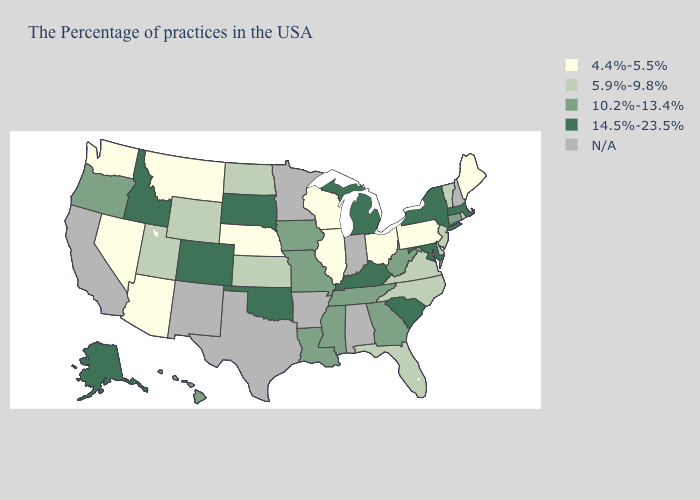What is the value of Maine?
Quick response, please. 4.4%-5.5%. What is the lowest value in the South?
Concise answer only. 5.9%-9.8%. What is the value of Maryland?
Give a very brief answer. 14.5%-23.5%. Name the states that have a value in the range 5.9%-9.8%?
Short answer required. Rhode Island, Vermont, New Jersey, Delaware, Virginia, North Carolina, Florida, Kansas, North Dakota, Wyoming, Utah. What is the lowest value in the USA?
Quick response, please. 4.4%-5.5%. Name the states that have a value in the range N/A?
Keep it brief. New Hampshire, Indiana, Alabama, Arkansas, Minnesota, Texas, New Mexico, California. Name the states that have a value in the range 10.2%-13.4%?
Write a very short answer. Connecticut, West Virginia, Georgia, Tennessee, Mississippi, Louisiana, Missouri, Iowa, Oregon, Hawaii. Does the map have missing data?
Write a very short answer. Yes. What is the value of Michigan?
Concise answer only. 14.5%-23.5%. What is the value of Arizona?
Keep it brief. 4.4%-5.5%. Name the states that have a value in the range 5.9%-9.8%?
Write a very short answer. Rhode Island, Vermont, New Jersey, Delaware, Virginia, North Carolina, Florida, Kansas, North Dakota, Wyoming, Utah. Does the map have missing data?
Give a very brief answer. Yes. What is the value of Minnesota?
Write a very short answer. N/A. Name the states that have a value in the range 10.2%-13.4%?
Give a very brief answer. Connecticut, West Virginia, Georgia, Tennessee, Mississippi, Louisiana, Missouri, Iowa, Oregon, Hawaii. Among the states that border New Mexico , which have the lowest value?
Write a very short answer. Arizona. 